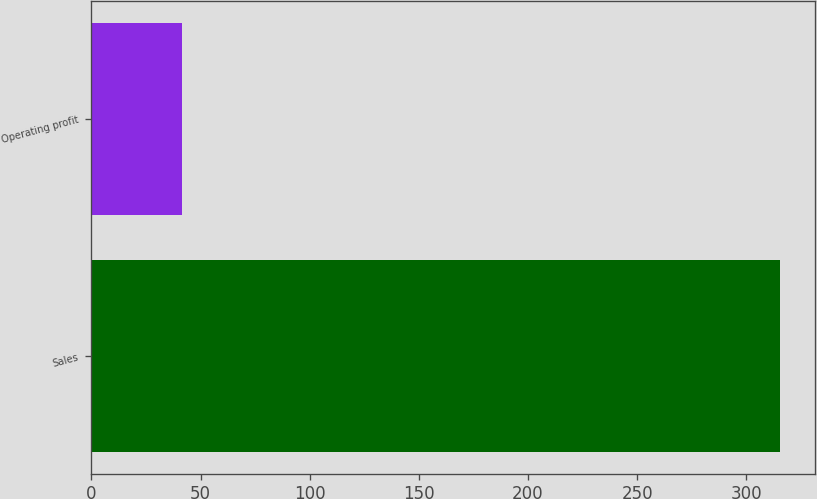<chart> <loc_0><loc_0><loc_500><loc_500><bar_chart><fcel>Sales<fcel>Operating profit<nl><fcel>315.6<fcel>41.5<nl></chart> 